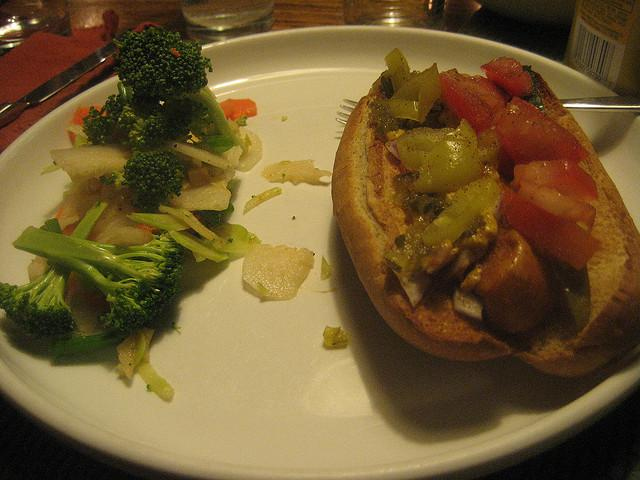What is on the left of the plate?

Choices:
A) eggs
B) apple
C) broccoli
D) pumpkin broccoli 